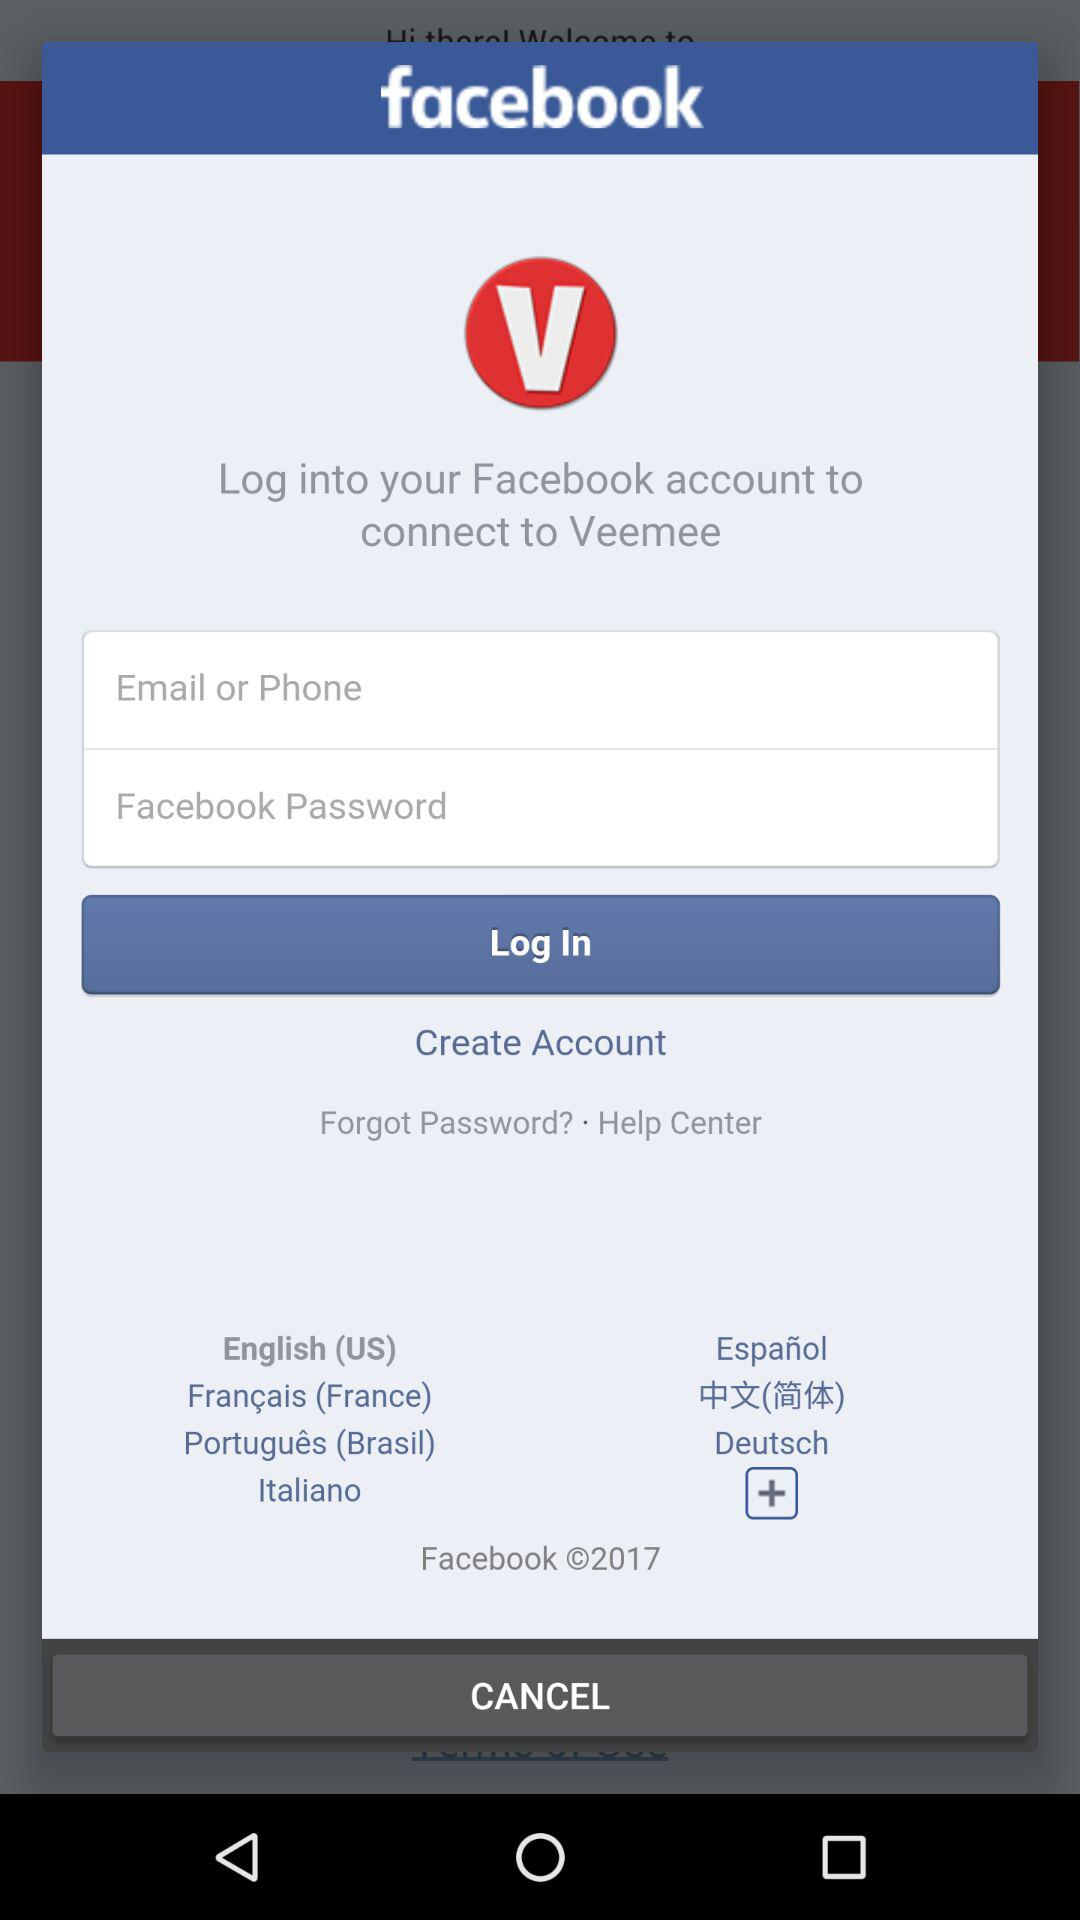How many text inputs are on the screen?
Answer the question using a single word or phrase. 2 